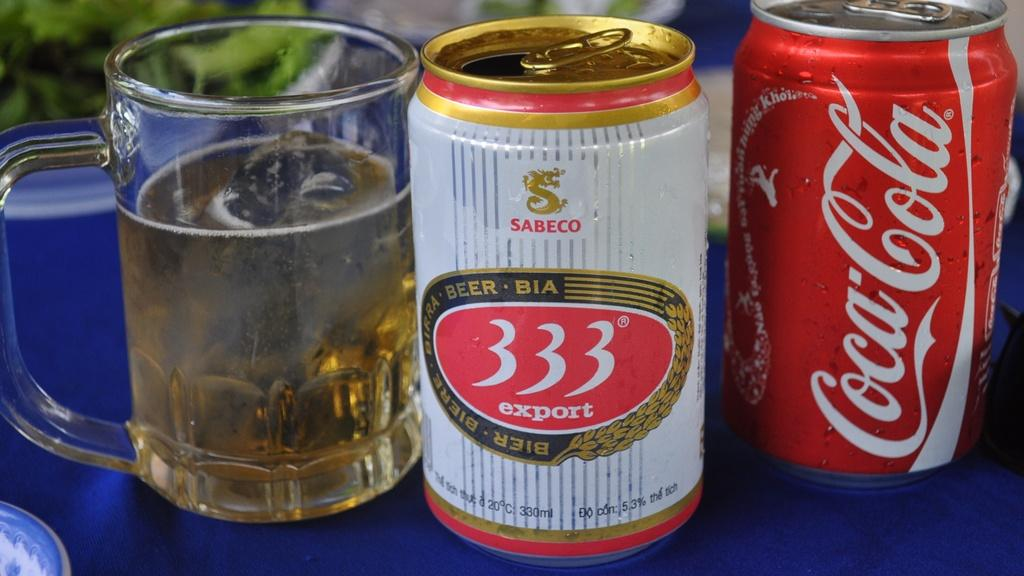<image>
Provide a brief description of the given image. 333 export beer can and glass next to a Coca Cola can 